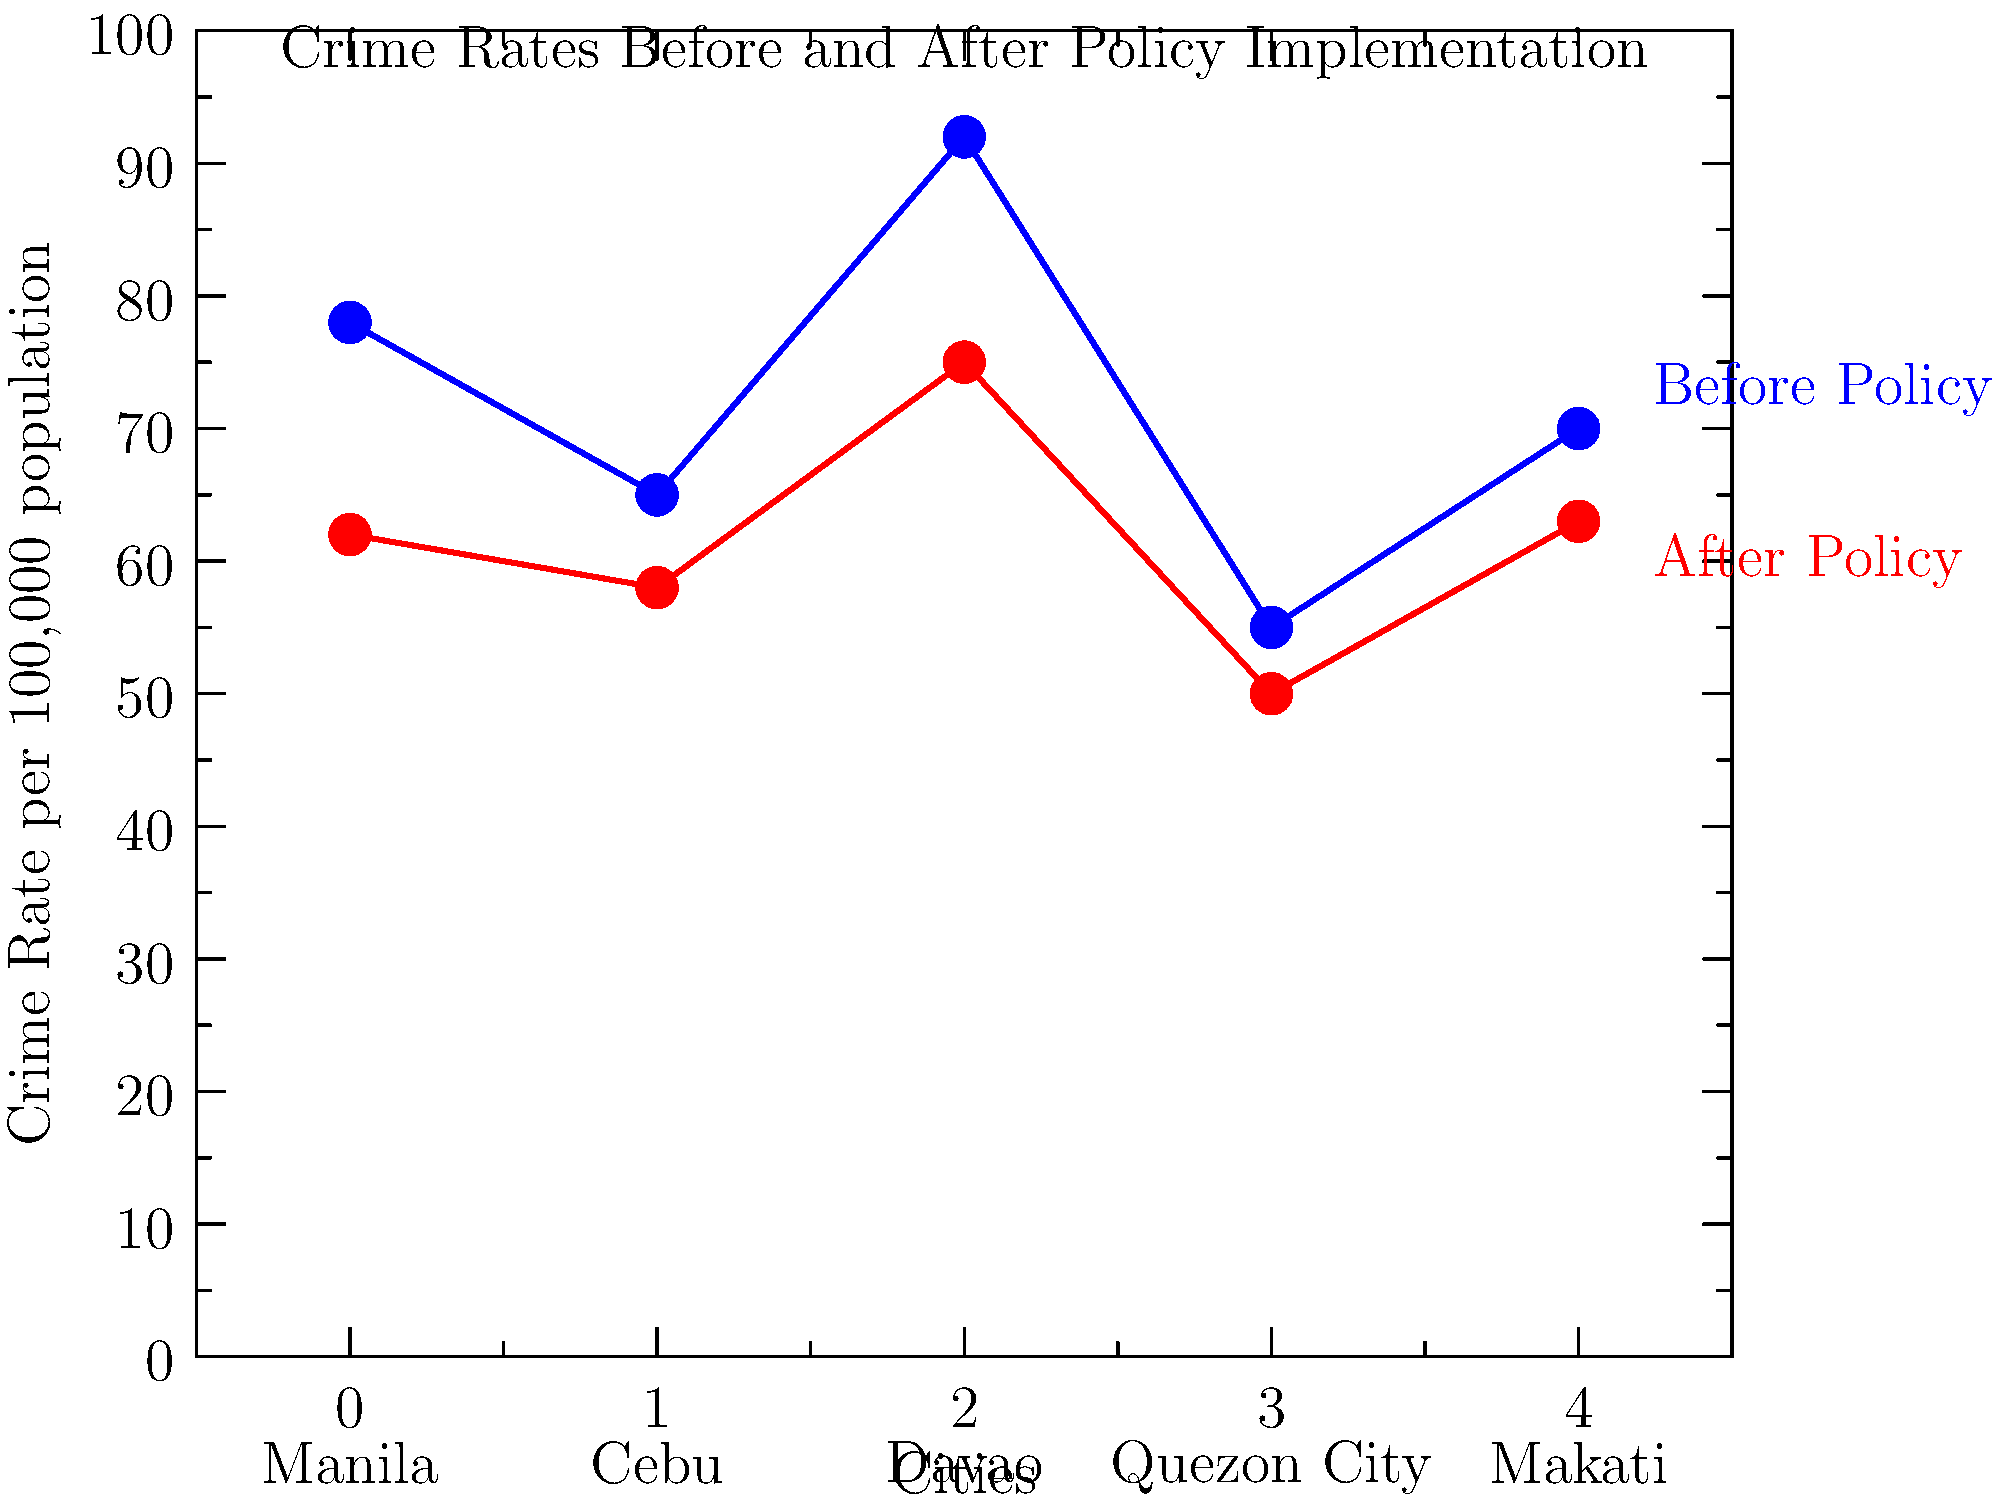Based on the chart comparing crime rates before and after implementing specific policies in major Philippine cities, which city showed the most significant percentage decrease in crime rate? To determine which city had the most significant percentage decrease in crime rate, we need to calculate the percentage change for each city:

1. Manila:
   Before: 78, After: 62
   Percentage change = $\frac{62 - 78}{78} \times 100\% = -20.51\%$

2. Cebu:
   Before: 65, After: 58
   Percentage change = $\frac{58 - 65}{65} \times 100\% = -10.77\%$

3. Davao:
   Before: 92, After: 75
   Percentage change = $\frac{75 - 92}{92} \times 100\% = -18.48\%$

4. Quezon City:
   Before: 55, After: 50
   Percentage change = $\frac{50 - 55}{55} \times 100\% = -9.09\%$

5. Makati:
   Before: 70, After: 63
   Percentage change = $\frac{63 - 70}{70} \times 100\% = -10.00\%$

Comparing these percentages, we can see that Manila had the largest percentage decrease at -20.51%.
Answer: Manila 